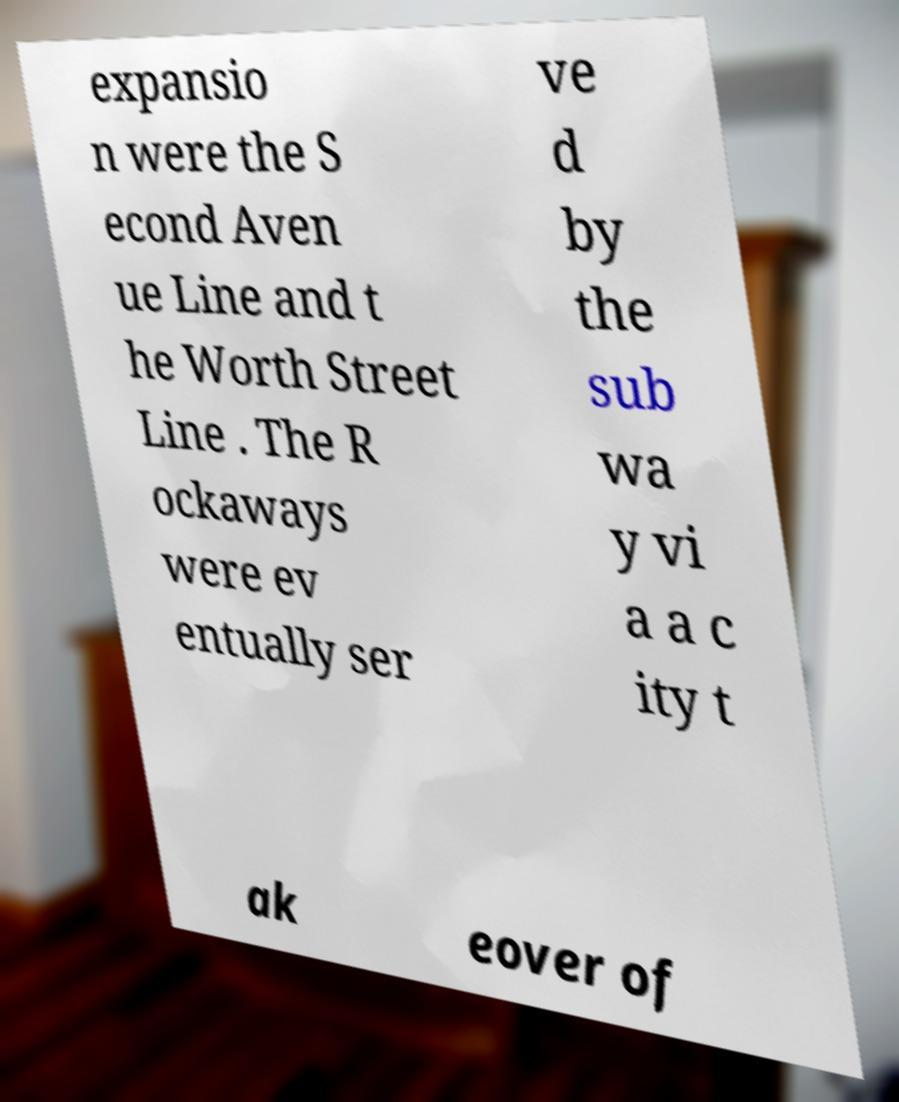Could you extract and type out the text from this image? expansio n were the S econd Aven ue Line and t he Worth Street Line . The R ockaways were ev entually ser ve d by the sub wa y vi a a c ity t ak eover of 